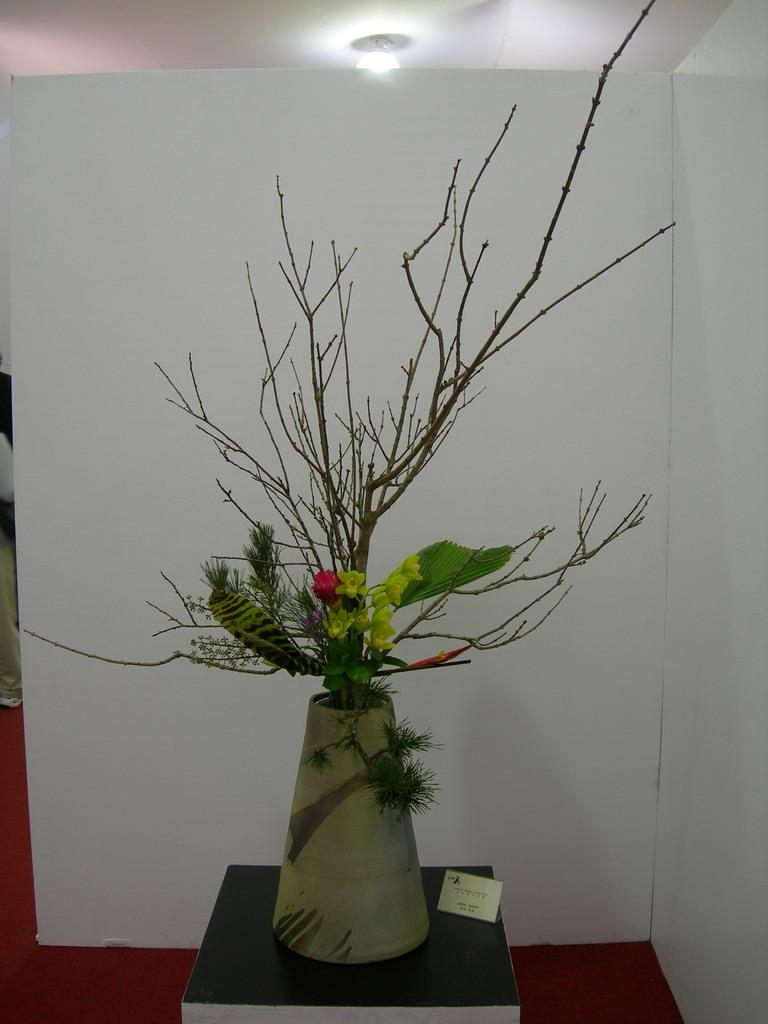What is the main subject of the image? There is a flower in the image. What color is the flower? The flower is red. What color is the background wall? The background wall is white. Can you describe the lighting in the image? There is a light visible in the image. What type of driving scene can be seen in the image? There is no driving scene present in the image; it features a red flower against a white background with a visible light. Is there a bathtub visible in the image? There is no bathtub present in the image. 